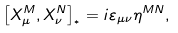Convert formula to latex. <formula><loc_0><loc_0><loc_500><loc_500>\left [ X _ { \mu } ^ { M } , X _ { \nu } ^ { N } \right ] _ { ^ { * } } = i \varepsilon _ { \mu \nu } \eta ^ { M N } ,</formula> 